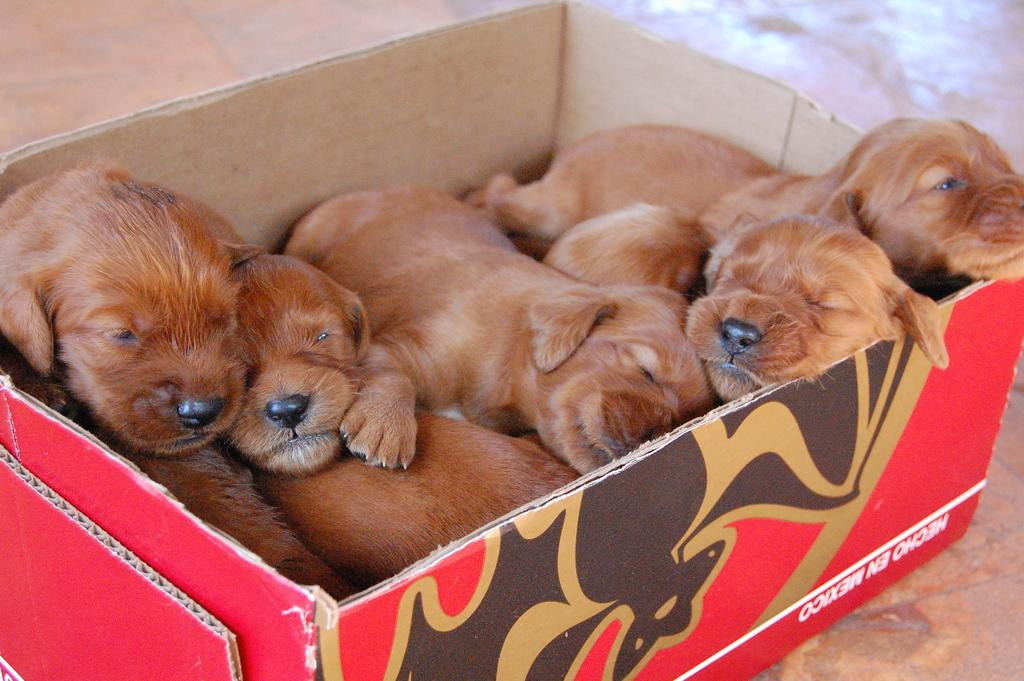What type of animals are in the image? There is a group of dogs in the image. What color are the dogs? The dogs are brown in color. How are the dogs contained in the image? The dogs are kept in a box made of cardboard. What surface can be seen in the image? There is a floor visible in the image. How does the earthquake affect the dogs' behavior in the image? There is no earthquake present in the image, so its effect on the dogs' behavior cannot be determined. 